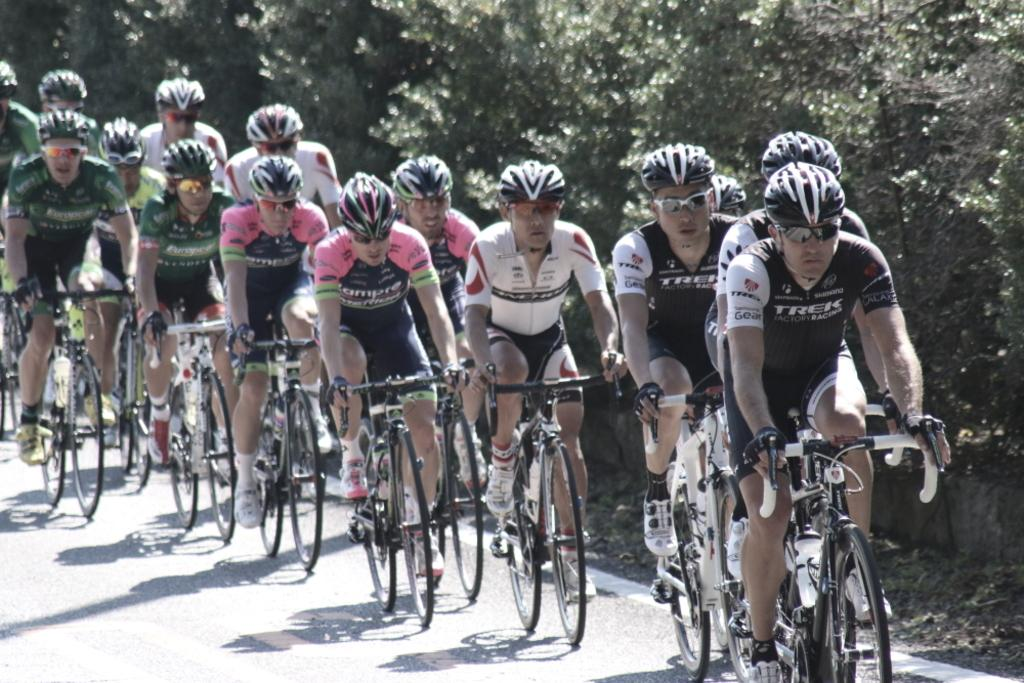What are the people in the image doing? The people in the image are cycling. Where are the people cycling? The people are on a road. What can be seen on the right side of the image? There are trees on the right side of the image. What type of songs are the people singing while cycling in the image? There is no indication in the image that the people are singing songs while cycling. 